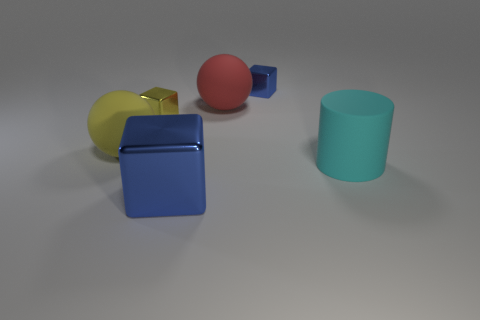Add 3 large blocks. How many objects exist? 9 Subtract all spheres. How many objects are left? 4 Add 3 blue things. How many blue things are left? 5 Add 5 cyan cylinders. How many cyan cylinders exist? 6 Subtract 0 blue cylinders. How many objects are left? 6 Subtract all blue metallic cylinders. Subtract all tiny metal objects. How many objects are left? 4 